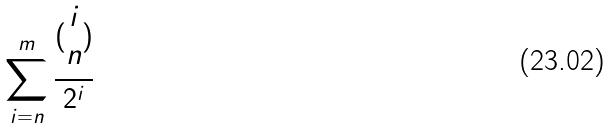Convert formula to latex. <formula><loc_0><loc_0><loc_500><loc_500>\sum _ { i = n } ^ { m } \frac { ( \begin{matrix} i \\ n \end{matrix} ) } { 2 ^ { i } }</formula> 